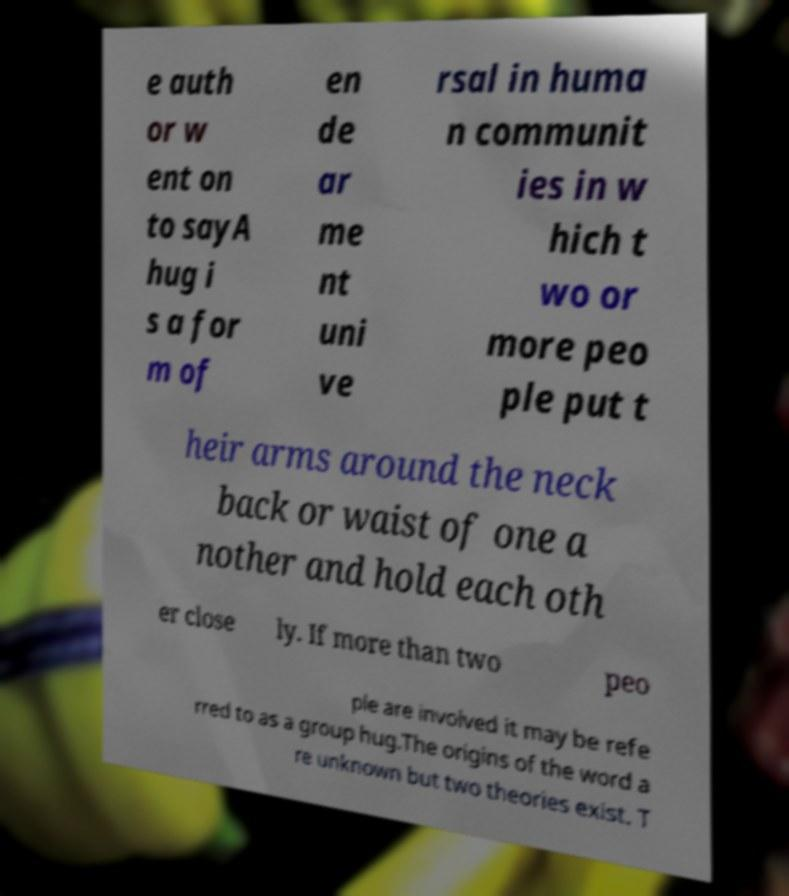What messages or text are displayed in this image? I need them in a readable, typed format. e auth or w ent on to sayA hug i s a for m of en de ar me nt uni ve rsal in huma n communit ies in w hich t wo or more peo ple put t heir arms around the neck back or waist of one a nother and hold each oth er close ly. If more than two peo ple are involved it may be refe rred to as a group hug.The origins of the word a re unknown but two theories exist. T 